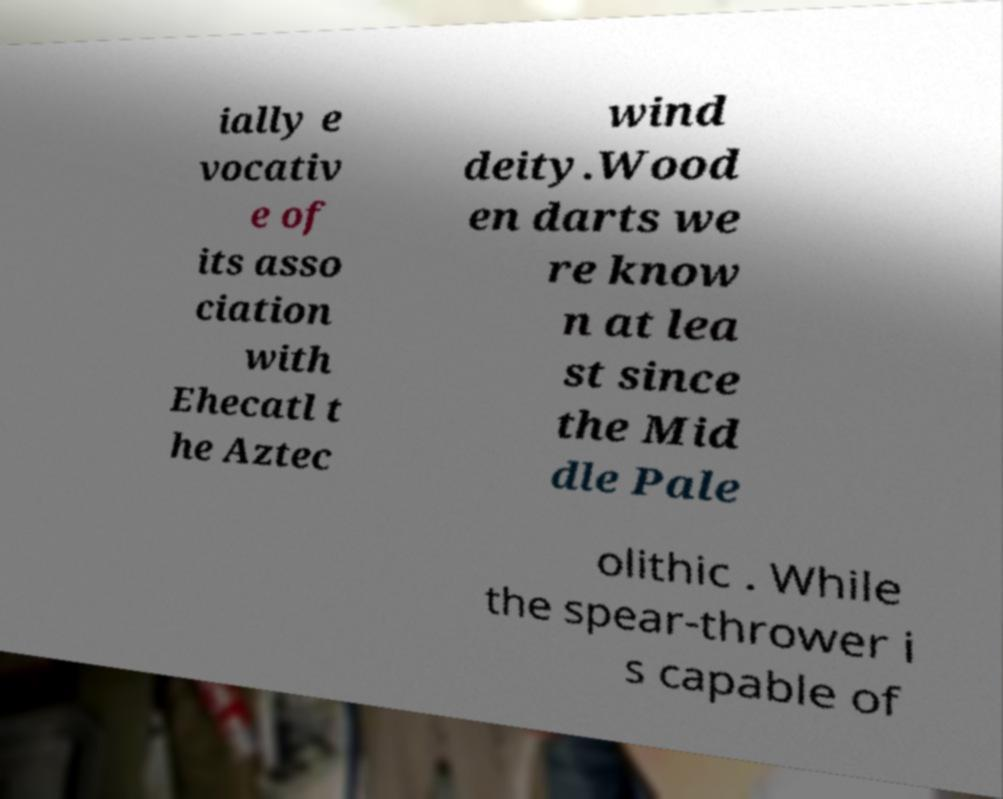What messages or text are displayed in this image? I need them in a readable, typed format. ially e vocativ e of its asso ciation with Ehecatl t he Aztec wind deity.Wood en darts we re know n at lea st since the Mid dle Pale olithic . While the spear-thrower i s capable of 